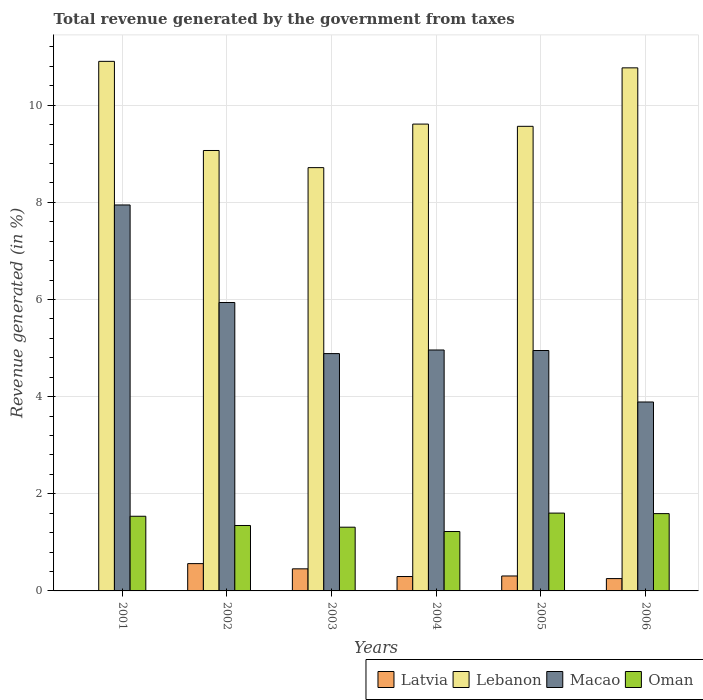Are the number of bars per tick equal to the number of legend labels?
Your answer should be very brief. No. Are the number of bars on each tick of the X-axis equal?
Your response must be concise. No. In how many cases, is the number of bars for a given year not equal to the number of legend labels?
Make the answer very short. 1. What is the total revenue generated in Latvia in 2002?
Ensure brevity in your answer.  0.56. Across all years, what is the maximum total revenue generated in Lebanon?
Make the answer very short. 10.9. Across all years, what is the minimum total revenue generated in Macao?
Ensure brevity in your answer.  3.89. What is the total total revenue generated in Lebanon in the graph?
Provide a short and direct response. 58.64. What is the difference between the total revenue generated in Latvia in 2004 and that in 2006?
Offer a terse response. 0.04. What is the difference between the total revenue generated in Lebanon in 2006 and the total revenue generated in Oman in 2002?
Your answer should be very brief. 9.42. What is the average total revenue generated in Lebanon per year?
Make the answer very short. 9.77. In the year 2005, what is the difference between the total revenue generated in Oman and total revenue generated in Latvia?
Keep it short and to the point. 1.29. What is the ratio of the total revenue generated in Lebanon in 2003 to that in 2006?
Offer a very short reply. 0.81. Is the difference between the total revenue generated in Oman in 2004 and 2005 greater than the difference between the total revenue generated in Latvia in 2004 and 2005?
Your response must be concise. No. What is the difference between the highest and the second highest total revenue generated in Macao?
Give a very brief answer. 2.01. What is the difference between the highest and the lowest total revenue generated in Macao?
Provide a short and direct response. 4.06. In how many years, is the total revenue generated in Oman greater than the average total revenue generated in Oman taken over all years?
Your answer should be very brief. 3. Are all the bars in the graph horizontal?
Your answer should be compact. No. How many years are there in the graph?
Your answer should be very brief. 6. What is the difference between two consecutive major ticks on the Y-axis?
Make the answer very short. 2. Does the graph contain any zero values?
Provide a short and direct response. Yes. Does the graph contain grids?
Your answer should be very brief. Yes. How many legend labels are there?
Ensure brevity in your answer.  4. How are the legend labels stacked?
Give a very brief answer. Horizontal. What is the title of the graph?
Offer a very short reply. Total revenue generated by the government from taxes. Does "Canada" appear as one of the legend labels in the graph?
Provide a short and direct response. No. What is the label or title of the Y-axis?
Offer a terse response. Revenue generated (in %). What is the Revenue generated (in %) in Lebanon in 2001?
Your response must be concise. 10.9. What is the Revenue generated (in %) in Macao in 2001?
Provide a short and direct response. 7.95. What is the Revenue generated (in %) of Oman in 2001?
Ensure brevity in your answer.  1.54. What is the Revenue generated (in %) of Latvia in 2002?
Your answer should be compact. 0.56. What is the Revenue generated (in %) of Lebanon in 2002?
Keep it short and to the point. 9.07. What is the Revenue generated (in %) in Macao in 2002?
Give a very brief answer. 5.94. What is the Revenue generated (in %) in Oman in 2002?
Your response must be concise. 1.35. What is the Revenue generated (in %) in Latvia in 2003?
Your answer should be compact. 0.45. What is the Revenue generated (in %) of Lebanon in 2003?
Your response must be concise. 8.72. What is the Revenue generated (in %) in Macao in 2003?
Provide a short and direct response. 4.89. What is the Revenue generated (in %) in Oman in 2003?
Ensure brevity in your answer.  1.31. What is the Revenue generated (in %) in Latvia in 2004?
Your response must be concise. 0.3. What is the Revenue generated (in %) in Lebanon in 2004?
Offer a very short reply. 9.61. What is the Revenue generated (in %) in Macao in 2004?
Your answer should be compact. 4.96. What is the Revenue generated (in %) in Oman in 2004?
Your response must be concise. 1.22. What is the Revenue generated (in %) of Latvia in 2005?
Keep it short and to the point. 0.31. What is the Revenue generated (in %) in Lebanon in 2005?
Offer a terse response. 9.57. What is the Revenue generated (in %) of Macao in 2005?
Your answer should be compact. 4.95. What is the Revenue generated (in %) in Oman in 2005?
Offer a terse response. 1.6. What is the Revenue generated (in %) of Latvia in 2006?
Ensure brevity in your answer.  0.25. What is the Revenue generated (in %) in Lebanon in 2006?
Provide a succinct answer. 10.77. What is the Revenue generated (in %) in Macao in 2006?
Keep it short and to the point. 3.89. What is the Revenue generated (in %) in Oman in 2006?
Make the answer very short. 1.59. Across all years, what is the maximum Revenue generated (in %) of Latvia?
Ensure brevity in your answer.  0.56. Across all years, what is the maximum Revenue generated (in %) in Lebanon?
Offer a terse response. 10.9. Across all years, what is the maximum Revenue generated (in %) of Macao?
Offer a terse response. 7.95. Across all years, what is the maximum Revenue generated (in %) in Oman?
Offer a terse response. 1.6. Across all years, what is the minimum Revenue generated (in %) of Latvia?
Give a very brief answer. 0. Across all years, what is the minimum Revenue generated (in %) of Lebanon?
Your answer should be very brief. 8.72. Across all years, what is the minimum Revenue generated (in %) of Macao?
Your answer should be very brief. 3.89. Across all years, what is the minimum Revenue generated (in %) in Oman?
Your answer should be very brief. 1.22. What is the total Revenue generated (in %) in Latvia in the graph?
Ensure brevity in your answer.  1.88. What is the total Revenue generated (in %) of Lebanon in the graph?
Offer a terse response. 58.64. What is the total Revenue generated (in %) of Macao in the graph?
Ensure brevity in your answer.  32.57. What is the total Revenue generated (in %) in Oman in the graph?
Offer a terse response. 8.61. What is the difference between the Revenue generated (in %) of Lebanon in 2001 and that in 2002?
Your answer should be very brief. 1.84. What is the difference between the Revenue generated (in %) of Macao in 2001 and that in 2002?
Your answer should be compact. 2.01. What is the difference between the Revenue generated (in %) of Oman in 2001 and that in 2002?
Offer a very short reply. 0.19. What is the difference between the Revenue generated (in %) in Lebanon in 2001 and that in 2003?
Keep it short and to the point. 2.19. What is the difference between the Revenue generated (in %) of Macao in 2001 and that in 2003?
Ensure brevity in your answer.  3.06. What is the difference between the Revenue generated (in %) of Oman in 2001 and that in 2003?
Keep it short and to the point. 0.23. What is the difference between the Revenue generated (in %) of Lebanon in 2001 and that in 2004?
Make the answer very short. 1.29. What is the difference between the Revenue generated (in %) in Macao in 2001 and that in 2004?
Ensure brevity in your answer.  2.99. What is the difference between the Revenue generated (in %) of Oman in 2001 and that in 2004?
Provide a short and direct response. 0.31. What is the difference between the Revenue generated (in %) of Lebanon in 2001 and that in 2005?
Provide a succinct answer. 1.34. What is the difference between the Revenue generated (in %) of Macao in 2001 and that in 2005?
Make the answer very short. 3. What is the difference between the Revenue generated (in %) in Oman in 2001 and that in 2005?
Offer a terse response. -0.06. What is the difference between the Revenue generated (in %) in Lebanon in 2001 and that in 2006?
Give a very brief answer. 0.13. What is the difference between the Revenue generated (in %) of Macao in 2001 and that in 2006?
Keep it short and to the point. 4.06. What is the difference between the Revenue generated (in %) in Oman in 2001 and that in 2006?
Your response must be concise. -0.05. What is the difference between the Revenue generated (in %) of Latvia in 2002 and that in 2003?
Give a very brief answer. 0.11. What is the difference between the Revenue generated (in %) in Lebanon in 2002 and that in 2003?
Ensure brevity in your answer.  0.35. What is the difference between the Revenue generated (in %) of Macao in 2002 and that in 2003?
Offer a terse response. 1.05. What is the difference between the Revenue generated (in %) in Oman in 2002 and that in 2003?
Offer a terse response. 0.03. What is the difference between the Revenue generated (in %) of Latvia in 2002 and that in 2004?
Offer a terse response. 0.27. What is the difference between the Revenue generated (in %) in Lebanon in 2002 and that in 2004?
Ensure brevity in your answer.  -0.54. What is the difference between the Revenue generated (in %) in Macao in 2002 and that in 2004?
Give a very brief answer. 0.98. What is the difference between the Revenue generated (in %) of Oman in 2002 and that in 2004?
Provide a succinct answer. 0.12. What is the difference between the Revenue generated (in %) of Latvia in 2002 and that in 2005?
Provide a short and direct response. 0.25. What is the difference between the Revenue generated (in %) in Lebanon in 2002 and that in 2005?
Make the answer very short. -0.5. What is the difference between the Revenue generated (in %) in Macao in 2002 and that in 2005?
Make the answer very short. 0.99. What is the difference between the Revenue generated (in %) of Oman in 2002 and that in 2005?
Provide a short and direct response. -0.26. What is the difference between the Revenue generated (in %) in Latvia in 2002 and that in 2006?
Ensure brevity in your answer.  0.31. What is the difference between the Revenue generated (in %) of Lebanon in 2002 and that in 2006?
Your response must be concise. -1.7. What is the difference between the Revenue generated (in %) in Macao in 2002 and that in 2006?
Give a very brief answer. 2.05. What is the difference between the Revenue generated (in %) in Oman in 2002 and that in 2006?
Ensure brevity in your answer.  -0.24. What is the difference between the Revenue generated (in %) in Latvia in 2003 and that in 2004?
Ensure brevity in your answer.  0.16. What is the difference between the Revenue generated (in %) in Lebanon in 2003 and that in 2004?
Your answer should be very brief. -0.9. What is the difference between the Revenue generated (in %) of Macao in 2003 and that in 2004?
Make the answer very short. -0.07. What is the difference between the Revenue generated (in %) of Oman in 2003 and that in 2004?
Offer a very short reply. 0.09. What is the difference between the Revenue generated (in %) of Latvia in 2003 and that in 2005?
Provide a succinct answer. 0.15. What is the difference between the Revenue generated (in %) in Lebanon in 2003 and that in 2005?
Your answer should be very brief. -0.85. What is the difference between the Revenue generated (in %) in Macao in 2003 and that in 2005?
Provide a short and direct response. -0.06. What is the difference between the Revenue generated (in %) in Oman in 2003 and that in 2005?
Keep it short and to the point. -0.29. What is the difference between the Revenue generated (in %) in Latvia in 2003 and that in 2006?
Offer a very short reply. 0.2. What is the difference between the Revenue generated (in %) in Lebanon in 2003 and that in 2006?
Offer a very short reply. -2.05. What is the difference between the Revenue generated (in %) in Oman in 2003 and that in 2006?
Offer a terse response. -0.28. What is the difference between the Revenue generated (in %) of Latvia in 2004 and that in 2005?
Offer a terse response. -0.01. What is the difference between the Revenue generated (in %) of Lebanon in 2004 and that in 2005?
Provide a succinct answer. 0.05. What is the difference between the Revenue generated (in %) of Macao in 2004 and that in 2005?
Make the answer very short. 0.01. What is the difference between the Revenue generated (in %) in Oman in 2004 and that in 2005?
Offer a terse response. -0.38. What is the difference between the Revenue generated (in %) of Latvia in 2004 and that in 2006?
Ensure brevity in your answer.  0.04. What is the difference between the Revenue generated (in %) in Lebanon in 2004 and that in 2006?
Offer a terse response. -1.16. What is the difference between the Revenue generated (in %) in Macao in 2004 and that in 2006?
Make the answer very short. 1.07. What is the difference between the Revenue generated (in %) of Oman in 2004 and that in 2006?
Your answer should be very brief. -0.37. What is the difference between the Revenue generated (in %) of Latvia in 2005 and that in 2006?
Ensure brevity in your answer.  0.05. What is the difference between the Revenue generated (in %) in Lebanon in 2005 and that in 2006?
Give a very brief answer. -1.2. What is the difference between the Revenue generated (in %) of Macao in 2005 and that in 2006?
Your response must be concise. 1.06. What is the difference between the Revenue generated (in %) in Oman in 2005 and that in 2006?
Ensure brevity in your answer.  0.01. What is the difference between the Revenue generated (in %) of Lebanon in 2001 and the Revenue generated (in %) of Macao in 2002?
Offer a terse response. 4.97. What is the difference between the Revenue generated (in %) in Lebanon in 2001 and the Revenue generated (in %) in Oman in 2002?
Ensure brevity in your answer.  9.56. What is the difference between the Revenue generated (in %) of Macao in 2001 and the Revenue generated (in %) of Oman in 2002?
Your answer should be very brief. 6.6. What is the difference between the Revenue generated (in %) of Lebanon in 2001 and the Revenue generated (in %) of Macao in 2003?
Provide a succinct answer. 6.02. What is the difference between the Revenue generated (in %) in Lebanon in 2001 and the Revenue generated (in %) in Oman in 2003?
Your response must be concise. 9.59. What is the difference between the Revenue generated (in %) in Macao in 2001 and the Revenue generated (in %) in Oman in 2003?
Offer a very short reply. 6.63. What is the difference between the Revenue generated (in %) in Lebanon in 2001 and the Revenue generated (in %) in Macao in 2004?
Your answer should be compact. 5.94. What is the difference between the Revenue generated (in %) of Lebanon in 2001 and the Revenue generated (in %) of Oman in 2004?
Offer a terse response. 9.68. What is the difference between the Revenue generated (in %) in Macao in 2001 and the Revenue generated (in %) in Oman in 2004?
Your answer should be compact. 6.72. What is the difference between the Revenue generated (in %) of Lebanon in 2001 and the Revenue generated (in %) of Macao in 2005?
Give a very brief answer. 5.95. What is the difference between the Revenue generated (in %) of Lebanon in 2001 and the Revenue generated (in %) of Oman in 2005?
Keep it short and to the point. 9.3. What is the difference between the Revenue generated (in %) of Macao in 2001 and the Revenue generated (in %) of Oman in 2005?
Ensure brevity in your answer.  6.35. What is the difference between the Revenue generated (in %) of Lebanon in 2001 and the Revenue generated (in %) of Macao in 2006?
Your answer should be compact. 7.01. What is the difference between the Revenue generated (in %) of Lebanon in 2001 and the Revenue generated (in %) of Oman in 2006?
Your answer should be compact. 9.31. What is the difference between the Revenue generated (in %) of Macao in 2001 and the Revenue generated (in %) of Oman in 2006?
Give a very brief answer. 6.36. What is the difference between the Revenue generated (in %) of Latvia in 2002 and the Revenue generated (in %) of Lebanon in 2003?
Your answer should be very brief. -8.15. What is the difference between the Revenue generated (in %) in Latvia in 2002 and the Revenue generated (in %) in Macao in 2003?
Your response must be concise. -4.32. What is the difference between the Revenue generated (in %) of Latvia in 2002 and the Revenue generated (in %) of Oman in 2003?
Offer a very short reply. -0.75. What is the difference between the Revenue generated (in %) of Lebanon in 2002 and the Revenue generated (in %) of Macao in 2003?
Make the answer very short. 4.18. What is the difference between the Revenue generated (in %) of Lebanon in 2002 and the Revenue generated (in %) of Oman in 2003?
Your response must be concise. 7.76. What is the difference between the Revenue generated (in %) in Macao in 2002 and the Revenue generated (in %) in Oman in 2003?
Your answer should be compact. 4.63. What is the difference between the Revenue generated (in %) of Latvia in 2002 and the Revenue generated (in %) of Lebanon in 2004?
Your answer should be compact. -9.05. What is the difference between the Revenue generated (in %) in Latvia in 2002 and the Revenue generated (in %) in Macao in 2004?
Ensure brevity in your answer.  -4.4. What is the difference between the Revenue generated (in %) in Latvia in 2002 and the Revenue generated (in %) in Oman in 2004?
Provide a succinct answer. -0.66. What is the difference between the Revenue generated (in %) of Lebanon in 2002 and the Revenue generated (in %) of Macao in 2004?
Give a very brief answer. 4.11. What is the difference between the Revenue generated (in %) in Lebanon in 2002 and the Revenue generated (in %) in Oman in 2004?
Make the answer very short. 7.85. What is the difference between the Revenue generated (in %) in Macao in 2002 and the Revenue generated (in %) in Oman in 2004?
Ensure brevity in your answer.  4.72. What is the difference between the Revenue generated (in %) of Latvia in 2002 and the Revenue generated (in %) of Lebanon in 2005?
Keep it short and to the point. -9. What is the difference between the Revenue generated (in %) in Latvia in 2002 and the Revenue generated (in %) in Macao in 2005?
Your answer should be compact. -4.39. What is the difference between the Revenue generated (in %) in Latvia in 2002 and the Revenue generated (in %) in Oman in 2005?
Make the answer very short. -1.04. What is the difference between the Revenue generated (in %) of Lebanon in 2002 and the Revenue generated (in %) of Macao in 2005?
Provide a short and direct response. 4.12. What is the difference between the Revenue generated (in %) of Lebanon in 2002 and the Revenue generated (in %) of Oman in 2005?
Make the answer very short. 7.47. What is the difference between the Revenue generated (in %) of Macao in 2002 and the Revenue generated (in %) of Oman in 2005?
Offer a very short reply. 4.34. What is the difference between the Revenue generated (in %) in Latvia in 2002 and the Revenue generated (in %) in Lebanon in 2006?
Provide a short and direct response. -10.21. What is the difference between the Revenue generated (in %) of Latvia in 2002 and the Revenue generated (in %) of Macao in 2006?
Keep it short and to the point. -3.33. What is the difference between the Revenue generated (in %) in Latvia in 2002 and the Revenue generated (in %) in Oman in 2006?
Your answer should be very brief. -1.03. What is the difference between the Revenue generated (in %) in Lebanon in 2002 and the Revenue generated (in %) in Macao in 2006?
Offer a very short reply. 5.18. What is the difference between the Revenue generated (in %) in Lebanon in 2002 and the Revenue generated (in %) in Oman in 2006?
Ensure brevity in your answer.  7.48. What is the difference between the Revenue generated (in %) in Macao in 2002 and the Revenue generated (in %) in Oman in 2006?
Offer a very short reply. 4.35. What is the difference between the Revenue generated (in %) of Latvia in 2003 and the Revenue generated (in %) of Lebanon in 2004?
Make the answer very short. -9.16. What is the difference between the Revenue generated (in %) of Latvia in 2003 and the Revenue generated (in %) of Macao in 2004?
Ensure brevity in your answer.  -4.51. What is the difference between the Revenue generated (in %) in Latvia in 2003 and the Revenue generated (in %) in Oman in 2004?
Your response must be concise. -0.77. What is the difference between the Revenue generated (in %) of Lebanon in 2003 and the Revenue generated (in %) of Macao in 2004?
Your answer should be compact. 3.75. What is the difference between the Revenue generated (in %) in Lebanon in 2003 and the Revenue generated (in %) in Oman in 2004?
Offer a very short reply. 7.49. What is the difference between the Revenue generated (in %) in Macao in 2003 and the Revenue generated (in %) in Oman in 2004?
Your answer should be very brief. 3.66. What is the difference between the Revenue generated (in %) in Latvia in 2003 and the Revenue generated (in %) in Lebanon in 2005?
Offer a very short reply. -9.11. What is the difference between the Revenue generated (in %) of Latvia in 2003 and the Revenue generated (in %) of Macao in 2005?
Your answer should be very brief. -4.5. What is the difference between the Revenue generated (in %) of Latvia in 2003 and the Revenue generated (in %) of Oman in 2005?
Your answer should be compact. -1.15. What is the difference between the Revenue generated (in %) of Lebanon in 2003 and the Revenue generated (in %) of Macao in 2005?
Your answer should be compact. 3.77. What is the difference between the Revenue generated (in %) in Lebanon in 2003 and the Revenue generated (in %) in Oman in 2005?
Offer a very short reply. 7.11. What is the difference between the Revenue generated (in %) in Macao in 2003 and the Revenue generated (in %) in Oman in 2005?
Offer a very short reply. 3.28. What is the difference between the Revenue generated (in %) of Latvia in 2003 and the Revenue generated (in %) of Lebanon in 2006?
Your answer should be compact. -10.32. What is the difference between the Revenue generated (in %) of Latvia in 2003 and the Revenue generated (in %) of Macao in 2006?
Offer a very short reply. -3.44. What is the difference between the Revenue generated (in %) of Latvia in 2003 and the Revenue generated (in %) of Oman in 2006?
Your answer should be compact. -1.14. What is the difference between the Revenue generated (in %) of Lebanon in 2003 and the Revenue generated (in %) of Macao in 2006?
Ensure brevity in your answer.  4.83. What is the difference between the Revenue generated (in %) of Lebanon in 2003 and the Revenue generated (in %) of Oman in 2006?
Offer a very short reply. 7.12. What is the difference between the Revenue generated (in %) in Macao in 2003 and the Revenue generated (in %) in Oman in 2006?
Your response must be concise. 3.29. What is the difference between the Revenue generated (in %) of Latvia in 2004 and the Revenue generated (in %) of Lebanon in 2005?
Offer a very short reply. -9.27. What is the difference between the Revenue generated (in %) of Latvia in 2004 and the Revenue generated (in %) of Macao in 2005?
Make the answer very short. -4.65. What is the difference between the Revenue generated (in %) of Latvia in 2004 and the Revenue generated (in %) of Oman in 2005?
Offer a very short reply. -1.31. What is the difference between the Revenue generated (in %) in Lebanon in 2004 and the Revenue generated (in %) in Macao in 2005?
Provide a succinct answer. 4.66. What is the difference between the Revenue generated (in %) in Lebanon in 2004 and the Revenue generated (in %) in Oman in 2005?
Ensure brevity in your answer.  8.01. What is the difference between the Revenue generated (in %) in Macao in 2004 and the Revenue generated (in %) in Oman in 2005?
Offer a very short reply. 3.36. What is the difference between the Revenue generated (in %) of Latvia in 2004 and the Revenue generated (in %) of Lebanon in 2006?
Offer a very short reply. -10.47. What is the difference between the Revenue generated (in %) in Latvia in 2004 and the Revenue generated (in %) in Macao in 2006?
Provide a succinct answer. -3.59. What is the difference between the Revenue generated (in %) in Latvia in 2004 and the Revenue generated (in %) in Oman in 2006?
Your response must be concise. -1.3. What is the difference between the Revenue generated (in %) of Lebanon in 2004 and the Revenue generated (in %) of Macao in 2006?
Make the answer very short. 5.72. What is the difference between the Revenue generated (in %) in Lebanon in 2004 and the Revenue generated (in %) in Oman in 2006?
Ensure brevity in your answer.  8.02. What is the difference between the Revenue generated (in %) of Macao in 2004 and the Revenue generated (in %) of Oman in 2006?
Offer a very short reply. 3.37. What is the difference between the Revenue generated (in %) in Latvia in 2005 and the Revenue generated (in %) in Lebanon in 2006?
Keep it short and to the point. -10.46. What is the difference between the Revenue generated (in %) of Latvia in 2005 and the Revenue generated (in %) of Macao in 2006?
Your response must be concise. -3.58. What is the difference between the Revenue generated (in %) of Latvia in 2005 and the Revenue generated (in %) of Oman in 2006?
Offer a very short reply. -1.28. What is the difference between the Revenue generated (in %) of Lebanon in 2005 and the Revenue generated (in %) of Macao in 2006?
Offer a very short reply. 5.68. What is the difference between the Revenue generated (in %) in Lebanon in 2005 and the Revenue generated (in %) in Oman in 2006?
Your answer should be very brief. 7.97. What is the difference between the Revenue generated (in %) in Macao in 2005 and the Revenue generated (in %) in Oman in 2006?
Provide a succinct answer. 3.36. What is the average Revenue generated (in %) of Latvia per year?
Provide a short and direct response. 0.31. What is the average Revenue generated (in %) in Lebanon per year?
Your response must be concise. 9.77. What is the average Revenue generated (in %) of Macao per year?
Offer a very short reply. 5.43. What is the average Revenue generated (in %) of Oman per year?
Provide a succinct answer. 1.44. In the year 2001, what is the difference between the Revenue generated (in %) in Lebanon and Revenue generated (in %) in Macao?
Give a very brief answer. 2.96. In the year 2001, what is the difference between the Revenue generated (in %) of Lebanon and Revenue generated (in %) of Oman?
Offer a terse response. 9.37. In the year 2001, what is the difference between the Revenue generated (in %) in Macao and Revenue generated (in %) in Oman?
Your response must be concise. 6.41. In the year 2002, what is the difference between the Revenue generated (in %) in Latvia and Revenue generated (in %) in Lebanon?
Keep it short and to the point. -8.51. In the year 2002, what is the difference between the Revenue generated (in %) of Latvia and Revenue generated (in %) of Macao?
Provide a short and direct response. -5.38. In the year 2002, what is the difference between the Revenue generated (in %) of Latvia and Revenue generated (in %) of Oman?
Provide a short and direct response. -0.78. In the year 2002, what is the difference between the Revenue generated (in %) in Lebanon and Revenue generated (in %) in Macao?
Your answer should be very brief. 3.13. In the year 2002, what is the difference between the Revenue generated (in %) in Lebanon and Revenue generated (in %) in Oman?
Provide a short and direct response. 7.72. In the year 2002, what is the difference between the Revenue generated (in %) of Macao and Revenue generated (in %) of Oman?
Your answer should be very brief. 4.59. In the year 2003, what is the difference between the Revenue generated (in %) of Latvia and Revenue generated (in %) of Lebanon?
Offer a terse response. -8.26. In the year 2003, what is the difference between the Revenue generated (in %) of Latvia and Revenue generated (in %) of Macao?
Offer a very short reply. -4.43. In the year 2003, what is the difference between the Revenue generated (in %) of Latvia and Revenue generated (in %) of Oman?
Give a very brief answer. -0.86. In the year 2003, what is the difference between the Revenue generated (in %) of Lebanon and Revenue generated (in %) of Macao?
Provide a succinct answer. 3.83. In the year 2003, what is the difference between the Revenue generated (in %) in Lebanon and Revenue generated (in %) in Oman?
Offer a terse response. 7.4. In the year 2003, what is the difference between the Revenue generated (in %) of Macao and Revenue generated (in %) of Oman?
Your response must be concise. 3.57. In the year 2004, what is the difference between the Revenue generated (in %) in Latvia and Revenue generated (in %) in Lebanon?
Your answer should be compact. -9.32. In the year 2004, what is the difference between the Revenue generated (in %) of Latvia and Revenue generated (in %) of Macao?
Provide a succinct answer. -4.66. In the year 2004, what is the difference between the Revenue generated (in %) in Latvia and Revenue generated (in %) in Oman?
Your response must be concise. -0.93. In the year 2004, what is the difference between the Revenue generated (in %) of Lebanon and Revenue generated (in %) of Macao?
Your answer should be compact. 4.65. In the year 2004, what is the difference between the Revenue generated (in %) in Lebanon and Revenue generated (in %) in Oman?
Provide a succinct answer. 8.39. In the year 2004, what is the difference between the Revenue generated (in %) of Macao and Revenue generated (in %) of Oman?
Provide a succinct answer. 3.74. In the year 2005, what is the difference between the Revenue generated (in %) of Latvia and Revenue generated (in %) of Lebanon?
Provide a succinct answer. -9.26. In the year 2005, what is the difference between the Revenue generated (in %) in Latvia and Revenue generated (in %) in Macao?
Offer a very short reply. -4.64. In the year 2005, what is the difference between the Revenue generated (in %) of Latvia and Revenue generated (in %) of Oman?
Your answer should be compact. -1.29. In the year 2005, what is the difference between the Revenue generated (in %) of Lebanon and Revenue generated (in %) of Macao?
Your answer should be very brief. 4.62. In the year 2005, what is the difference between the Revenue generated (in %) in Lebanon and Revenue generated (in %) in Oman?
Keep it short and to the point. 7.96. In the year 2005, what is the difference between the Revenue generated (in %) in Macao and Revenue generated (in %) in Oman?
Provide a succinct answer. 3.35. In the year 2006, what is the difference between the Revenue generated (in %) in Latvia and Revenue generated (in %) in Lebanon?
Make the answer very short. -10.52. In the year 2006, what is the difference between the Revenue generated (in %) of Latvia and Revenue generated (in %) of Macao?
Offer a terse response. -3.64. In the year 2006, what is the difference between the Revenue generated (in %) of Latvia and Revenue generated (in %) of Oman?
Make the answer very short. -1.34. In the year 2006, what is the difference between the Revenue generated (in %) of Lebanon and Revenue generated (in %) of Macao?
Keep it short and to the point. 6.88. In the year 2006, what is the difference between the Revenue generated (in %) in Lebanon and Revenue generated (in %) in Oman?
Keep it short and to the point. 9.18. In the year 2006, what is the difference between the Revenue generated (in %) in Macao and Revenue generated (in %) in Oman?
Keep it short and to the point. 2.3. What is the ratio of the Revenue generated (in %) in Lebanon in 2001 to that in 2002?
Keep it short and to the point. 1.2. What is the ratio of the Revenue generated (in %) in Macao in 2001 to that in 2002?
Ensure brevity in your answer.  1.34. What is the ratio of the Revenue generated (in %) of Oman in 2001 to that in 2002?
Give a very brief answer. 1.14. What is the ratio of the Revenue generated (in %) of Lebanon in 2001 to that in 2003?
Offer a very short reply. 1.25. What is the ratio of the Revenue generated (in %) in Macao in 2001 to that in 2003?
Ensure brevity in your answer.  1.63. What is the ratio of the Revenue generated (in %) in Oman in 2001 to that in 2003?
Provide a short and direct response. 1.17. What is the ratio of the Revenue generated (in %) in Lebanon in 2001 to that in 2004?
Provide a short and direct response. 1.13. What is the ratio of the Revenue generated (in %) in Macao in 2001 to that in 2004?
Provide a succinct answer. 1.6. What is the ratio of the Revenue generated (in %) in Oman in 2001 to that in 2004?
Keep it short and to the point. 1.26. What is the ratio of the Revenue generated (in %) in Lebanon in 2001 to that in 2005?
Your answer should be compact. 1.14. What is the ratio of the Revenue generated (in %) in Macao in 2001 to that in 2005?
Keep it short and to the point. 1.61. What is the ratio of the Revenue generated (in %) in Oman in 2001 to that in 2005?
Make the answer very short. 0.96. What is the ratio of the Revenue generated (in %) in Lebanon in 2001 to that in 2006?
Your answer should be compact. 1.01. What is the ratio of the Revenue generated (in %) in Macao in 2001 to that in 2006?
Your response must be concise. 2.04. What is the ratio of the Revenue generated (in %) of Oman in 2001 to that in 2006?
Make the answer very short. 0.97. What is the ratio of the Revenue generated (in %) in Latvia in 2002 to that in 2003?
Make the answer very short. 1.24. What is the ratio of the Revenue generated (in %) in Lebanon in 2002 to that in 2003?
Give a very brief answer. 1.04. What is the ratio of the Revenue generated (in %) in Macao in 2002 to that in 2003?
Make the answer very short. 1.22. What is the ratio of the Revenue generated (in %) of Oman in 2002 to that in 2003?
Provide a short and direct response. 1.03. What is the ratio of the Revenue generated (in %) in Latvia in 2002 to that in 2004?
Your answer should be compact. 1.9. What is the ratio of the Revenue generated (in %) of Lebanon in 2002 to that in 2004?
Make the answer very short. 0.94. What is the ratio of the Revenue generated (in %) of Macao in 2002 to that in 2004?
Provide a short and direct response. 1.2. What is the ratio of the Revenue generated (in %) of Oman in 2002 to that in 2004?
Your response must be concise. 1.1. What is the ratio of the Revenue generated (in %) of Latvia in 2002 to that in 2005?
Make the answer very short. 1.83. What is the ratio of the Revenue generated (in %) of Lebanon in 2002 to that in 2005?
Your answer should be very brief. 0.95. What is the ratio of the Revenue generated (in %) in Macao in 2002 to that in 2005?
Ensure brevity in your answer.  1.2. What is the ratio of the Revenue generated (in %) in Oman in 2002 to that in 2005?
Offer a terse response. 0.84. What is the ratio of the Revenue generated (in %) of Latvia in 2002 to that in 2006?
Provide a short and direct response. 2.21. What is the ratio of the Revenue generated (in %) of Lebanon in 2002 to that in 2006?
Offer a very short reply. 0.84. What is the ratio of the Revenue generated (in %) in Macao in 2002 to that in 2006?
Your answer should be very brief. 1.53. What is the ratio of the Revenue generated (in %) of Oman in 2002 to that in 2006?
Your answer should be compact. 0.85. What is the ratio of the Revenue generated (in %) of Latvia in 2003 to that in 2004?
Your answer should be very brief. 1.53. What is the ratio of the Revenue generated (in %) of Lebanon in 2003 to that in 2004?
Your response must be concise. 0.91. What is the ratio of the Revenue generated (in %) in Oman in 2003 to that in 2004?
Ensure brevity in your answer.  1.07. What is the ratio of the Revenue generated (in %) in Latvia in 2003 to that in 2005?
Offer a very short reply. 1.48. What is the ratio of the Revenue generated (in %) in Lebanon in 2003 to that in 2005?
Ensure brevity in your answer.  0.91. What is the ratio of the Revenue generated (in %) of Macao in 2003 to that in 2005?
Offer a very short reply. 0.99. What is the ratio of the Revenue generated (in %) in Oman in 2003 to that in 2005?
Ensure brevity in your answer.  0.82. What is the ratio of the Revenue generated (in %) in Latvia in 2003 to that in 2006?
Ensure brevity in your answer.  1.79. What is the ratio of the Revenue generated (in %) of Lebanon in 2003 to that in 2006?
Provide a succinct answer. 0.81. What is the ratio of the Revenue generated (in %) of Macao in 2003 to that in 2006?
Provide a short and direct response. 1.26. What is the ratio of the Revenue generated (in %) in Oman in 2003 to that in 2006?
Give a very brief answer. 0.82. What is the ratio of the Revenue generated (in %) of Lebanon in 2004 to that in 2005?
Provide a succinct answer. 1. What is the ratio of the Revenue generated (in %) in Macao in 2004 to that in 2005?
Provide a short and direct response. 1. What is the ratio of the Revenue generated (in %) in Oman in 2004 to that in 2005?
Make the answer very short. 0.76. What is the ratio of the Revenue generated (in %) of Latvia in 2004 to that in 2006?
Give a very brief answer. 1.17. What is the ratio of the Revenue generated (in %) of Lebanon in 2004 to that in 2006?
Your answer should be very brief. 0.89. What is the ratio of the Revenue generated (in %) of Macao in 2004 to that in 2006?
Ensure brevity in your answer.  1.28. What is the ratio of the Revenue generated (in %) of Oman in 2004 to that in 2006?
Your response must be concise. 0.77. What is the ratio of the Revenue generated (in %) of Latvia in 2005 to that in 2006?
Make the answer very short. 1.21. What is the ratio of the Revenue generated (in %) of Lebanon in 2005 to that in 2006?
Make the answer very short. 0.89. What is the ratio of the Revenue generated (in %) in Macao in 2005 to that in 2006?
Ensure brevity in your answer.  1.27. What is the ratio of the Revenue generated (in %) of Oman in 2005 to that in 2006?
Keep it short and to the point. 1.01. What is the difference between the highest and the second highest Revenue generated (in %) in Latvia?
Keep it short and to the point. 0.11. What is the difference between the highest and the second highest Revenue generated (in %) in Lebanon?
Offer a terse response. 0.13. What is the difference between the highest and the second highest Revenue generated (in %) of Macao?
Give a very brief answer. 2.01. What is the difference between the highest and the second highest Revenue generated (in %) in Oman?
Provide a short and direct response. 0.01. What is the difference between the highest and the lowest Revenue generated (in %) of Latvia?
Keep it short and to the point. 0.56. What is the difference between the highest and the lowest Revenue generated (in %) in Lebanon?
Offer a very short reply. 2.19. What is the difference between the highest and the lowest Revenue generated (in %) in Macao?
Offer a very short reply. 4.06. What is the difference between the highest and the lowest Revenue generated (in %) in Oman?
Your answer should be very brief. 0.38. 